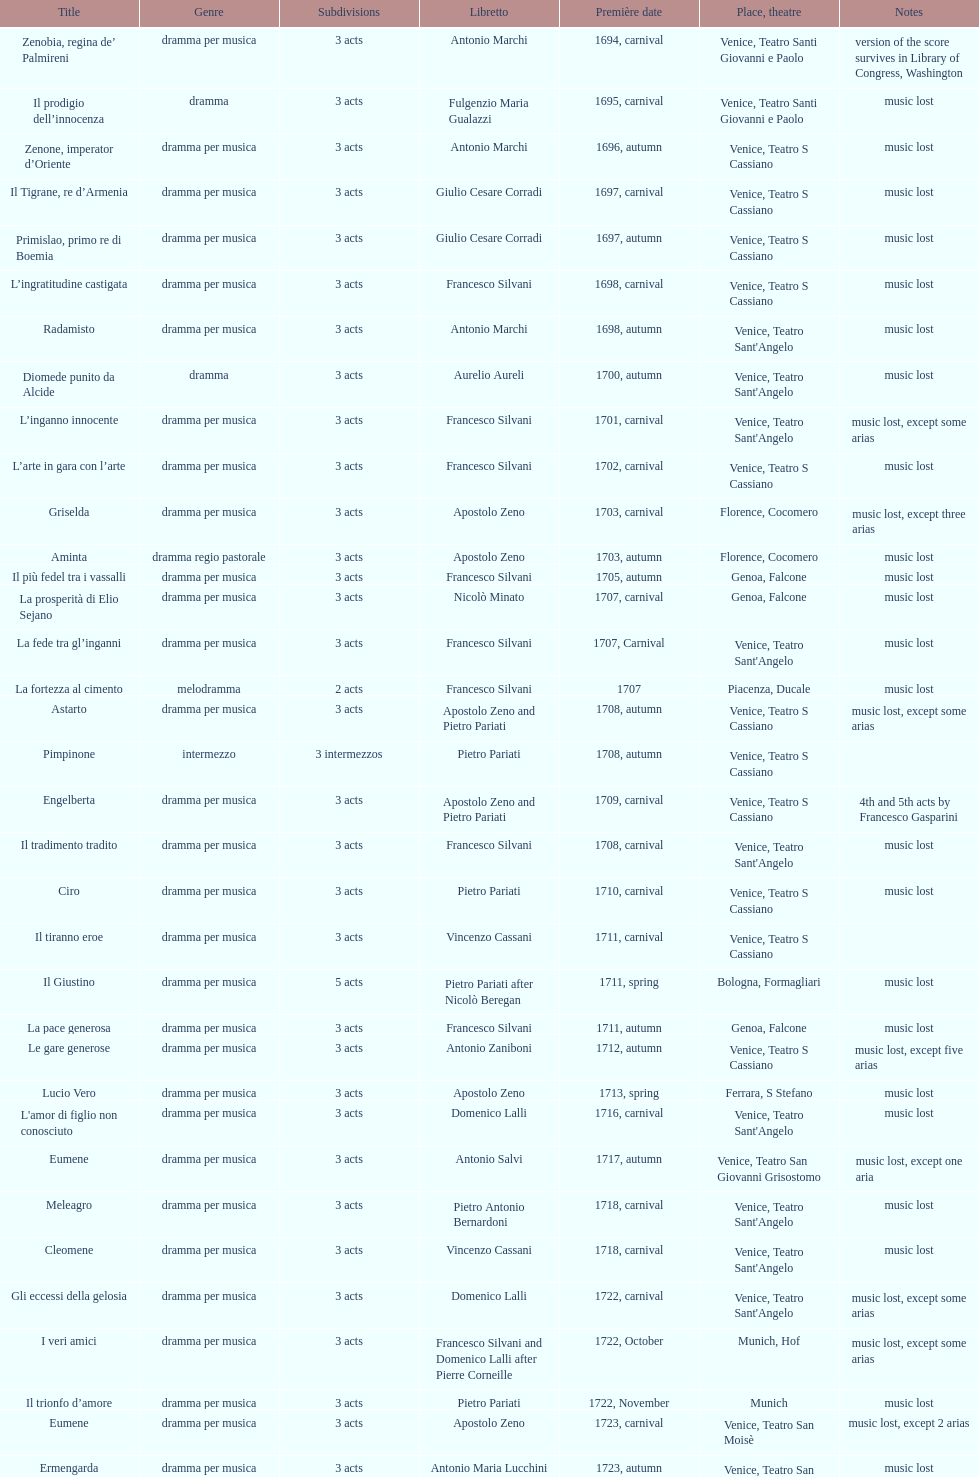What number of acts does il giustino have? 5. I'm looking to parse the entire table for insights. Could you assist me with that? {'header': ['Title', 'Genre', 'Sub\xaddivisions', 'Libretto', 'Première date', 'Place, theatre', 'Notes'], 'rows': [['Zenobia, regina de’ Palmireni', 'dramma per musica', '3 acts', 'Antonio Marchi', '1694, carnival', 'Venice, Teatro Santi Giovanni e Paolo', 'version of the score survives in Library of Congress, Washington'], ['Il prodigio dell’innocenza', 'dramma', '3 acts', 'Fulgenzio Maria Gualazzi', '1695, carnival', 'Venice, Teatro Santi Giovanni e Paolo', 'music lost'], ['Zenone, imperator d’Oriente', 'dramma per musica', '3 acts', 'Antonio Marchi', '1696, autumn', 'Venice, Teatro S Cassiano', 'music lost'], ['Il Tigrane, re d’Armenia', 'dramma per musica', '3 acts', 'Giulio Cesare Corradi', '1697, carnival', 'Venice, Teatro S Cassiano', 'music lost'], ['Primislao, primo re di Boemia', 'dramma per musica', '3 acts', 'Giulio Cesare Corradi', '1697, autumn', 'Venice, Teatro S Cassiano', 'music lost'], ['L’ingratitudine castigata', 'dramma per musica', '3 acts', 'Francesco Silvani', '1698, carnival', 'Venice, Teatro S Cassiano', 'music lost'], ['Radamisto', 'dramma per musica', '3 acts', 'Antonio Marchi', '1698, autumn', "Venice, Teatro Sant'Angelo", 'music lost'], ['Diomede punito da Alcide', 'dramma', '3 acts', 'Aurelio Aureli', '1700, autumn', "Venice, Teatro Sant'Angelo", 'music lost'], ['L’inganno innocente', 'dramma per musica', '3 acts', 'Francesco Silvani', '1701, carnival', "Venice, Teatro Sant'Angelo", 'music lost, except some arias'], ['L’arte in gara con l’arte', 'dramma per musica', '3 acts', 'Francesco Silvani', '1702, carnival', 'Venice, Teatro S Cassiano', 'music lost'], ['Griselda', 'dramma per musica', '3 acts', 'Apostolo Zeno', '1703, carnival', 'Florence, Cocomero', 'music lost, except three arias'], ['Aminta', 'dramma regio pastorale', '3 acts', 'Apostolo Zeno', '1703, autumn', 'Florence, Cocomero', 'music lost'], ['Il più fedel tra i vassalli', 'dramma per musica', '3 acts', 'Francesco Silvani', '1705, autumn', 'Genoa, Falcone', 'music lost'], ['La prosperità di Elio Sejano', 'dramma per musica', '3 acts', 'Nicolò Minato', '1707, carnival', 'Genoa, Falcone', 'music lost'], ['La fede tra gl’inganni', 'dramma per musica', '3 acts', 'Francesco Silvani', '1707, Carnival', "Venice, Teatro Sant'Angelo", 'music lost'], ['La fortezza al cimento', 'melodramma', '2 acts', 'Francesco Silvani', '1707', 'Piacenza, Ducale', 'music lost'], ['Astarto', 'dramma per musica', '3 acts', 'Apostolo Zeno and Pietro Pariati', '1708, autumn', 'Venice, Teatro S Cassiano', 'music lost, except some arias'], ['Pimpinone', 'intermezzo', '3 intermezzos', 'Pietro Pariati', '1708, autumn', 'Venice, Teatro S Cassiano', ''], ['Engelberta', 'dramma per musica', '3 acts', 'Apostolo Zeno and Pietro Pariati', '1709, carnival', 'Venice, Teatro S Cassiano', '4th and 5th acts by Francesco Gasparini'], ['Il tradimento tradito', 'dramma per musica', '3 acts', 'Francesco Silvani', '1708, carnival', "Venice, Teatro Sant'Angelo", 'music lost'], ['Ciro', 'dramma per musica', '3 acts', 'Pietro Pariati', '1710, carnival', 'Venice, Teatro S Cassiano', 'music lost'], ['Il tiranno eroe', 'dramma per musica', '3 acts', 'Vincenzo Cassani', '1711, carnival', 'Venice, Teatro S Cassiano', ''], ['Il Giustino', 'dramma per musica', '5 acts', 'Pietro Pariati after Nicolò Beregan', '1711, spring', 'Bologna, Formagliari', 'music lost'], ['La pace generosa', 'dramma per musica', '3 acts', 'Francesco Silvani', '1711, autumn', 'Genoa, Falcone', 'music lost'], ['Le gare generose', 'dramma per musica', '3 acts', 'Antonio Zaniboni', '1712, autumn', 'Venice, Teatro S Cassiano', 'music lost, except five arias'], ['Lucio Vero', 'dramma per musica', '3 acts', 'Apostolo Zeno', '1713, spring', 'Ferrara, S Stefano', 'music lost'], ["L'amor di figlio non conosciuto", 'dramma per musica', '3 acts', 'Domenico Lalli', '1716, carnival', "Venice, Teatro Sant'Angelo", 'music lost'], ['Eumene', 'dramma per musica', '3 acts', 'Antonio Salvi', '1717, autumn', 'Venice, Teatro San Giovanni Grisostomo', 'music lost, except one aria'], ['Meleagro', 'dramma per musica', '3 acts', 'Pietro Antonio Bernardoni', '1718, carnival', "Venice, Teatro Sant'Angelo", 'music lost'], ['Cleomene', 'dramma per musica', '3 acts', 'Vincenzo Cassani', '1718, carnival', "Venice, Teatro Sant'Angelo", 'music lost'], ['Gli eccessi della gelosia', 'dramma per musica', '3 acts', 'Domenico Lalli', '1722, carnival', "Venice, Teatro Sant'Angelo", 'music lost, except some arias'], ['I veri amici', 'dramma per musica', '3 acts', 'Francesco Silvani and Domenico Lalli after Pierre Corneille', '1722, October', 'Munich, Hof', 'music lost, except some arias'], ['Il trionfo d’amore', 'dramma per musica', '3 acts', 'Pietro Pariati', '1722, November', 'Munich', 'music lost'], ['Eumene', 'dramma per musica', '3 acts', 'Apostolo Zeno', '1723, carnival', 'Venice, Teatro San Moisè', 'music lost, except 2 arias'], ['Ermengarda', 'dramma per musica', '3 acts', 'Antonio Maria Lucchini', '1723, autumn', 'Venice, Teatro San Moisè', 'music lost'], ['Antigono, tutore di Filippo, re di Macedonia', 'tragedia', '5 acts', 'Giovanni Piazzon', '1724, carnival', 'Venice, Teatro San Moisè', '5th act by Giovanni Porta, music lost'], ['Scipione nelle Spagne', 'dramma per musica', '3 acts', 'Apostolo Zeno', '1724, Ascension', 'Venice, Teatro San Samuele', 'music lost'], ['Laodice', 'dramma per musica', '3 acts', 'Angelo Schietti', '1724, autumn', 'Venice, Teatro San Moisè', 'music lost, except 2 arias'], ['Didone abbandonata', 'tragedia', '3 acts', 'Metastasio', '1725, carnival', 'Venice, Teatro S Cassiano', 'music lost'], ["L'impresario delle Isole Canarie", 'intermezzo', '2 acts', 'Metastasio', '1725, carnival', 'Venice, Teatro S Cassiano', 'music lost'], ['Alcina delusa da Ruggero', 'dramma per musica', '3 acts', 'Antonio Marchi', '1725, autumn', 'Venice, Teatro S Cassiano', 'music lost'], ['I rivali generosi', 'dramma per musica', '3 acts', 'Apostolo Zeno', '1725', 'Brescia, Nuovo', ''], ['La Statira', 'dramma per musica', '3 acts', 'Apostolo Zeno and Pietro Pariati', '1726, Carnival', 'Rome, Teatro Capranica', ''], ['Malsazio e Fiammetta', 'intermezzo', '', '', '1726, Carnival', 'Rome, Teatro Capranica', ''], ['Il trionfo di Armida', 'dramma per musica', '3 acts', 'Girolamo Colatelli after Torquato Tasso', '1726, autumn', 'Venice, Teatro San Moisè', 'music lost'], ['L’incostanza schernita', 'dramma comico-pastorale', '3 acts', 'Vincenzo Cassani', '1727, Ascension', 'Venice, Teatro San Samuele', 'music lost, except some arias'], ['Le due rivali in amore', 'dramma per musica', '3 acts', 'Aurelio Aureli', '1728, autumn', 'Venice, Teatro San Moisè', 'music lost'], ['Il Satrapone', 'intermezzo', '', 'Salvi', '1729', 'Parma, Omodeo', ''], ['Li stratagemmi amorosi', 'dramma per musica', '3 acts', 'F Passerini', '1730, carnival', 'Venice, Teatro San Moisè', 'music lost'], ['Elenia', 'dramma per musica', '3 acts', 'Luisa Bergalli', '1730, carnival', "Venice, Teatro Sant'Angelo", 'music lost'], ['Merope', 'dramma', '3 acts', 'Apostolo Zeno', '1731, autumn', 'Prague, Sporck Theater', 'mostly by Albinoni, music lost'], ['Il più infedel tra gli amanti', 'dramma per musica', '3 acts', 'Angelo Schietti', '1731, autumn', 'Treviso, Dolphin', 'music lost'], ['Ardelinda', 'dramma', '3 acts', 'Bartolomeo Vitturi', '1732, autumn', "Venice, Teatro Sant'Angelo", 'music lost, except five arias'], ['Candalide', 'dramma per musica', '3 acts', 'Bartolomeo Vitturi', '1734, carnival', "Venice, Teatro Sant'Angelo", 'music lost'], ['Artamene', 'dramma per musica', '3 acts', 'Bartolomeo Vitturi', '1741, carnival', "Venice, Teatro Sant'Angelo", 'music lost']]} 